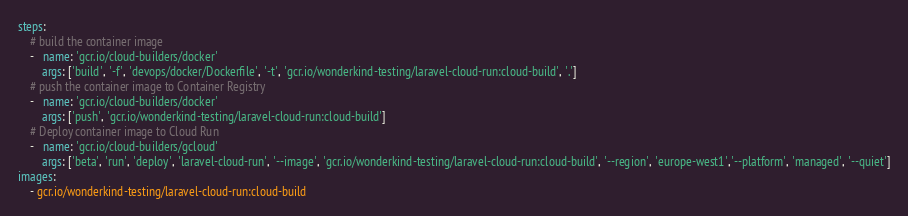Convert code to text. <code><loc_0><loc_0><loc_500><loc_500><_YAML_>steps:
    # build the container image
    -   name: 'gcr.io/cloud-builders/docker'
        args: ['build', '-f', 'devops/docker/Dockerfile', '-t', 'gcr.io/wonderkind-testing/laravel-cloud-run:cloud-build', '.']
    # push the container image to Container Registry
    -   name: 'gcr.io/cloud-builders/docker'
        args: ['push', 'gcr.io/wonderkind-testing/laravel-cloud-run:cloud-build']
    # Deploy container image to Cloud Run
    -   name: 'gcr.io/cloud-builders/gcloud'
        args: ['beta', 'run', 'deploy', 'laravel-cloud-run', '--image', 'gcr.io/wonderkind-testing/laravel-cloud-run:cloud-build', '--region', 'europe-west1','--platform', 'managed', '--quiet']
images:
    - gcr.io/wonderkind-testing/laravel-cloud-run:cloud-build
</code> 